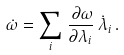Convert formula to latex. <formula><loc_0><loc_0><loc_500><loc_500>\dot { \omega } = \sum _ { i } \, \frac { \, \partial \omega } { \partial \lambda _ { i } } \, \dot { \lambda } _ { i } \, .</formula> 